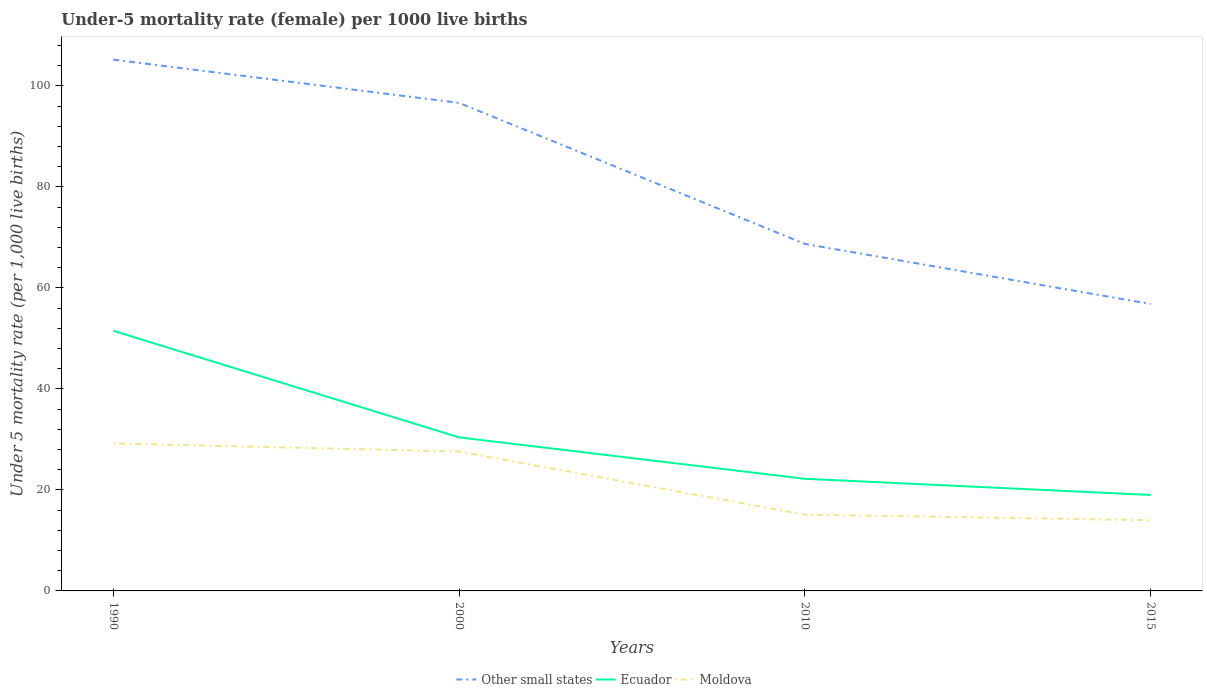Across all years, what is the maximum under-five mortality rate in Ecuador?
Ensure brevity in your answer.  19. In which year was the under-five mortality rate in Ecuador maximum?
Ensure brevity in your answer.  2015. What is the total under-five mortality rate in Ecuador in the graph?
Your answer should be very brief. 32.5. What is the difference between the highest and the second highest under-five mortality rate in Other small states?
Make the answer very short. 48.38. Is the under-five mortality rate in Ecuador strictly greater than the under-five mortality rate in Other small states over the years?
Your response must be concise. Yes. What is the difference between two consecutive major ticks on the Y-axis?
Provide a succinct answer. 20. Are the values on the major ticks of Y-axis written in scientific E-notation?
Offer a terse response. No. Does the graph contain any zero values?
Make the answer very short. No. Does the graph contain grids?
Keep it short and to the point. No. Where does the legend appear in the graph?
Give a very brief answer. Bottom center. How are the legend labels stacked?
Your response must be concise. Horizontal. What is the title of the graph?
Keep it short and to the point. Under-5 mortality rate (female) per 1000 live births. Does "Zimbabwe" appear as one of the legend labels in the graph?
Provide a short and direct response. No. What is the label or title of the X-axis?
Offer a terse response. Years. What is the label or title of the Y-axis?
Ensure brevity in your answer.  Under 5 mortality rate (per 1,0 live births). What is the Under 5 mortality rate (per 1,000 live births) in Other small states in 1990?
Provide a succinct answer. 105.19. What is the Under 5 mortality rate (per 1,000 live births) in Ecuador in 1990?
Ensure brevity in your answer.  51.5. What is the Under 5 mortality rate (per 1,000 live births) in Moldova in 1990?
Your answer should be compact. 29.2. What is the Under 5 mortality rate (per 1,000 live births) of Other small states in 2000?
Provide a succinct answer. 96.62. What is the Under 5 mortality rate (per 1,000 live births) of Ecuador in 2000?
Your response must be concise. 30.4. What is the Under 5 mortality rate (per 1,000 live births) of Moldova in 2000?
Your answer should be very brief. 27.6. What is the Under 5 mortality rate (per 1,000 live births) in Other small states in 2010?
Give a very brief answer. 68.7. What is the Under 5 mortality rate (per 1,000 live births) in Ecuador in 2010?
Offer a terse response. 22.2. What is the Under 5 mortality rate (per 1,000 live births) of Other small states in 2015?
Offer a terse response. 56.81. What is the Under 5 mortality rate (per 1,000 live births) in Ecuador in 2015?
Provide a succinct answer. 19. Across all years, what is the maximum Under 5 mortality rate (per 1,000 live births) of Other small states?
Your answer should be very brief. 105.19. Across all years, what is the maximum Under 5 mortality rate (per 1,000 live births) of Ecuador?
Your response must be concise. 51.5. Across all years, what is the maximum Under 5 mortality rate (per 1,000 live births) of Moldova?
Your answer should be very brief. 29.2. Across all years, what is the minimum Under 5 mortality rate (per 1,000 live births) in Other small states?
Your answer should be compact. 56.81. Across all years, what is the minimum Under 5 mortality rate (per 1,000 live births) of Ecuador?
Provide a succinct answer. 19. Across all years, what is the minimum Under 5 mortality rate (per 1,000 live births) in Moldova?
Offer a terse response. 14. What is the total Under 5 mortality rate (per 1,000 live births) in Other small states in the graph?
Make the answer very short. 327.33. What is the total Under 5 mortality rate (per 1,000 live births) of Ecuador in the graph?
Provide a succinct answer. 123.1. What is the total Under 5 mortality rate (per 1,000 live births) of Moldova in the graph?
Ensure brevity in your answer.  85.9. What is the difference between the Under 5 mortality rate (per 1,000 live births) of Other small states in 1990 and that in 2000?
Make the answer very short. 8.57. What is the difference between the Under 5 mortality rate (per 1,000 live births) in Ecuador in 1990 and that in 2000?
Provide a succinct answer. 21.1. What is the difference between the Under 5 mortality rate (per 1,000 live births) of Other small states in 1990 and that in 2010?
Offer a terse response. 36.49. What is the difference between the Under 5 mortality rate (per 1,000 live births) in Ecuador in 1990 and that in 2010?
Ensure brevity in your answer.  29.3. What is the difference between the Under 5 mortality rate (per 1,000 live births) of Other small states in 1990 and that in 2015?
Provide a succinct answer. 48.38. What is the difference between the Under 5 mortality rate (per 1,000 live births) in Ecuador in 1990 and that in 2015?
Your answer should be very brief. 32.5. What is the difference between the Under 5 mortality rate (per 1,000 live births) in Other small states in 2000 and that in 2010?
Your response must be concise. 27.92. What is the difference between the Under 5 mortality rate (per 1,000 live births) of Ecuador in 2000 and that in 2010?
Offer a terse response. 8.2. What is the difference between the Under 5 mortality rate (per 1,000 live births) in Moldova in 2000 and that in 2010?
Provide a succinct answer. 12.5. What is the difference between the Under 5 mortality rate (per 1,000 live births) in Other small states in 2000 and that in 2015?
Your answer should be very brief. 39.82. What is the difference between the Under 5 mortality rate (per 1,000 live births) of Ecuador in 2000 and that in 2015?
Your answer should be very brief. 11.4. What is the difference between the Under 5 mortality rate (per 1,000 live births) in Moldova in 2000 and that in 2015?
Make the answer very short. 13.6. What is the difference between the Under 5 mortality rate (per 1,000 live births) in Other small states in 2010 and that in 2015?
Provide a short and direct response. 11.9. What is the difference between the Under 5 mortality rate (per 1,000 live births) in Other small states in 1990 and the Under 5 mortality rate (per 1,000 live births) in Ecuador in 2000?
Make the answer very short. 74.79. What is the difference between the Under 5 mortality rate (per 1,000 live births) in Other small states in 1990 and the Under 5 mortality rate (per 1,000 live births) in Moldova in 2000?
Offer a terse response. 77.59. What is the difference between the Under 5 mortality rate (per 1,000 live births) in Ecuador in 1990 and the Under 5 mortality rate (per 1,000 live births) in Moldova in 2000?
Offer a terse response. 23.9. What is the difference between the Under 5 mortality rate (per 1,000 live births) in Other small states in 1990 and the Under 5 mortality rate (per 1,000 live births) in Ecuador in 2010?
Provide a short and direct response. 82.99. What is the difference between the Under 5 mortality rate (per 1,000 live births) in Other small states in 1990 and the Under 5 mortality rate (per 1,000 live births) in Moldova in 2010?
Provide a short and direct response. 90.09. What is the difference between the Under 5 mortality rate (per 1,000 live births) in Ecuador in 1990 and the Under 5 mortality rate (per 1,000 live births) in Moldova in 2010?
Your answer should be very brief. 36.4. What is the difference between the Under 5 mortality rate (per 1,000 live births) in Other small states in 1990 and the Under 5 mortality rate (per 1,000 live births) in Ecuador in 2015?
Offer a very short reply. 86.19. What is the difference between the Under 5 mortality rate (per 1,000 live births) of Other small states in 1990 and the Under 5 mortality rate (per 1,000 live births) of Moldova in 2015?
Provide a succinct answer. 91.19. What is the difference between the Under 5 mortality rate (per 1,000 live births) of Ecuador in 1990 and the Under 5 mortality rate (per 1,000 live births) of Moldova in 2015?
Offer a very short reply. 37.5. What is the difference between the Under 5 mortality rate (per 1,000 live births) in Other small states in 2000 and the Under 5 mortality rate (per 1,000 live births) in Ecuador in 2010?
Give a very brief answer. 74.42. What is the difference between the Under 5 mortality rate (per 1,000 live births) in Other small states in 2000 and the Under 5 mortality rate (per 1,000 live births) in Moldova in 2010?
Offer a terse response. 81.52. What is the difference between the Under 5 mortality rate (per 1,000 live births) of Ecuador in 2000 and the Under 5 mortality rate (per 1,000 live births) of Moldova in 2010?
Offer a terse response. 15.3. What is the difference between the Under 5 mortality rate (per 1,000 live births) in Other small states in 2000 and the Under 5 mortality rate (per 1,000 live births) in Ecuador in 2015?
Your answer should be compact. 77.62. What is the difference between the Under 5 mortality rate (per 1,000 live births) of Other small states in 2000 and the Under 5 mortality rate (per 1,000 live births) of Moldova in 2015?
Keep it short and to the point. 82.62. What is the difference between the Under 5 mortality rate (per 1,000 live births) in Ecuador in 2000 and the Under 5 mortality rate (per 1,000 live births) in Moldova in 2015?
Make the answer very short. 16.4. What is the difference between the Under 5 mortality rate (per 1,000 live births) of Other small states in 2010 and the Under 5 mortality rate (per 1,000 live births) of Ecuador in 2015?
Make the answer very short. 49.7. What is the difference between the Under 5 mortality rate (per 1,000 live births) in Other small states in 2010 and the Under 5 mortality rate (per 1,000 live births) in Moldova in 2015?
Offer a terse response. 54.7. What is the average Under 5 mortality rate (per 1,000 live births) in Other small states per year?
Give a very brief answer. 81.83. What is the average Under 5 mortality rate (per 1,000 live births) of Ecuador per year?
Provide a succinct answer. 30.77. What is the average Under 5 mortality rate (per 1,000 live births) of Moldova per year?
Offer a very short reply. 21.48. In the year 1990, what is the difference between the Under 5 mortality rate (per 1,000 live births) of Other small states and Under 5 mortality rate (per 1,000 live births) of Ecuador?
Your response must be concise. 53.69. In the year 1990, what is the difference between the Under 5 mortality rate (per 1,000 live births) in Other small states and Under 5 mortality rate (per 1,000 live births) in Moldova?
Your answer should be very brief. 75.99. In the year 1990, what is the difference between the Under 5 mortality rate (per 1,000 live births) of Ecuador and Under 5 mortality rate (per 1,000 live births) of Moldova?
Ensure brevity in your answer.  22.3. In the year 2000, what is the difference between the Under 5 mortality rate (per 1,000 live births) of Other small states and Under 5 mortality rate (per 1,000 live births) of Ecuador?
Provide a short and direct response. 66.22. In the year 2000, what is the difference between the Under 5 mortality rate (per 1,000 live births) of Other small states and Under 5 mortality rate (per 1,000 live births) of Moldova?
Provide a short and direct response. 69.02. In the year 2010, what is the difference between the Under 5 mortality rate (per 1,000 live births) in Other small states and Under 5 mortality rate (per 1,000 live births) in Ecuador?
Your answer should be very brief. 46.5. In the year 2010, what is the difference between the Under 5 mortality rate (per 1,000 live births) in Other small states and Under 5 mortality rate (per 1,000 live births) in Moldova?
Your answer should be compact. 53.6. In the year 2010, what is the difference between the Under 5 mortality rate (per 1,000 live births) in Ecuador and Under 5 mortality rate (per 1,000 live births) in Moldova?
Your answer should be very brief. 7.1. In the year 2015, what is the difference between the Under 5 mortality rate (per 1,000 live births) of Other small states and Under 5 mortality rate (per 1,000 live births) of Ecuador?
Provide a succinct answer. 37.81. In the year 2015, what is the difference between the Under 5 mortality rate (per 1,000 live births) of Other small states and Under 5 mortality rate (per 1,000 live births) of Moldova?
Keep it short and to the point. 42.81. In the year 2015, what is the difference between the Under 5 mortality rate (per 1,000 live births) in Ecuador and Under 5 mortality rate (per 1,000 live births) in Moldova?
Give a very brief answer. 5. What is the ratio of the Under 5 mortality rate (per 1,000 live births) in Other small states in 1990 to that in 2000?
Provide a succinct answer. 1.09. What is the ratio of the Under 5 mortality rate (per 1,000 live births) of Ecuador in 1990 to that in 2000?
Provide a short and direct response. 1.69. What is the ratio of the Under 5 mortality rate (per 1,000 live births) of Moldova in 1990 to that in 2000?
Your response must be concise. 1.06. What is the ratio of the Under 5 mortality rate (per 1,000 live births) of Other small states in 1990 to that in 2010?
Provide a succinct answer. 1.53. What is the ratio of the Under 5 mortality rate (per 1,000 live births) in Ecuador in 1990 to that in 2010?
Your answer should be very brief. 2.32. What is the ratio of the Under 5 mortality rate (per 1,000 live births) of Moldova in 1990 to that in 2010?
Provide a short and direct response. 1.93. What is the ratio of the Under 5 mortality rate (per 1,000 live births) in Other small states in 1990 to that in 2015?
Your response must be concise. 1.85. What is the ratio of the Under 5 mortality rate (per 1,000 live births) in Ecuador in 1990 to that in 2015?
Provide a short and direct response. 2.71. What is the ratio of the Under 5 mortality rate (per 1,000 live births) of Moldova in 1990 to that in 2015?
Your response must be concise. 2.09. What is the ratio of the Under 5 mortality rate (per 1,000 live births) in Other small states in 2000 to that in 2010?
Offer a terse response. 1.41. What is the ratio of the Under 5 mortality rate (per 1,000 live births) of Ecuador in 2000 to that in 2010?
Provide a succinct answer. 1.37. What is the ratio of the Under 5 mortality rate (per 1,000 live births) in Moldova in 2000 to that in 2010?
Provide a short and direct response. 1.83. What is the ratio of the Under 5 mortality rate (per 1,000 live births) in Other small states in 2000 to that in 2015?
Offer a very short reply. 1.7. What is the ratio of the Under 5 mortality rate (per 1,000 live births) of Moldova in 2000 to that in 2015?
Provide a succinct answer. 1.97. What is the ratio of the Under 5 mortality rate (per 1,000 live births) in Other small states in 2010 to that in 2015?
Your answer should be compact. 1.21. What is the ratio of the Under 5 mortality rate (per 1,000 live births) in Ecuador in 2010 to that in 2015?
Offer a very short reply. 1.17. What is the ratio of the Under 5 mortality rate (per 1,000 live births) of Moldova in 2010 to that in 2015?
Your response must be concise. 1.08. What is the difference between the highest and the second highest Under 5 mortality rate (per 1,000 live births) of Other small states?
Provide a succinct answer. 8.57. What is the difference between the highest and the second highest Under 5 mortality rate (per 1,000 live births) of Ecuador?
Offer a very short reply. 21.1. What is the difference between the highest and the second highest Under 5 mortality rate (per 1,000 live births) in Moldova?
Your answer should be very brief. 1.6. What is the difference between the highest and the lowest Under 5 mortality rate (per 1,000 live births) in Other small states?
Provide a succinct answer. 48.38. What is the difference between the highest and the lowest Under 5 mortality rate (per 1,000 live births) in Ecuador?
Give a very brief answer. 32.5. What is the difference between the highest and the lowest Under 5 mortality rate (per 1,000 live births) in Moldova?
Give a very brief answer. 15.2. 